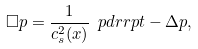Convert formula to latex. <formula><loc_0><loc_0><loc_500><loc_500>\square p = \frac { 1 } { c _ { s } ^ { 2 } ( x ) } \ p d r r p t - \Delta p ,</formula> 